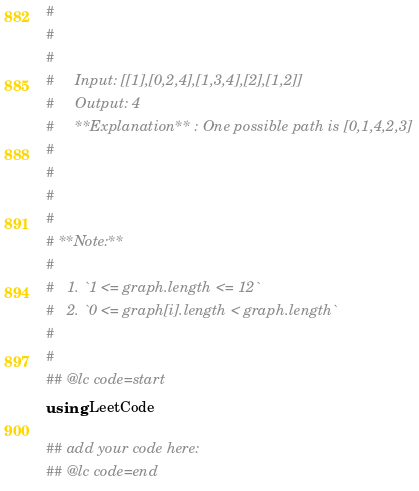Convert code to text. <code><loc_0><loc_0><loc_500><loc_500><_Julia_># 
#     
#     
#     Input: [[1],[0,2,4],[1,3,4],[2],[1,2]]
#     Output: 4
#     **Explanation** : One possible path is [0,1,4,2,3]
#     
# 
# 
# 
# **Note:**
# 
#   1. `1 <= graph.length <= 12`
#   2. `0 <= graph[i].length < graph.length`
# 
# 
## @lc code=start
using LeetCode

## add your code here:
## @lc code=end
</code> 